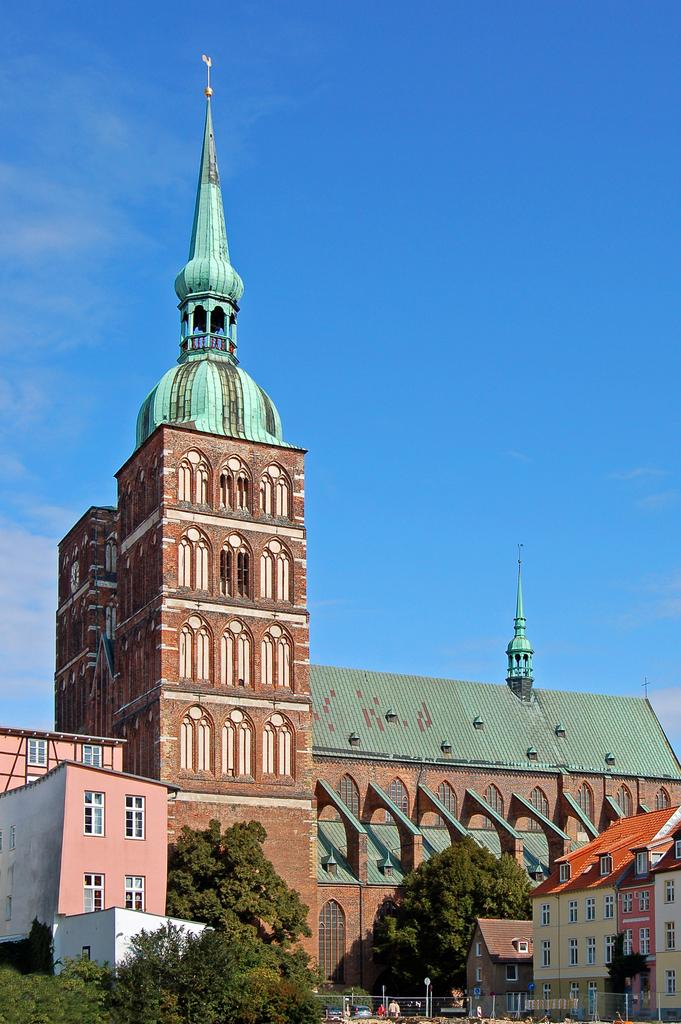What type of structures can be seen in the image? There are buildings in the image. What type of vegetation is present in the image? There are trees in the image. What type of ground surface is visible in the image? There is grass visible in the image. Are there any living beings present in the image? Yes, there are people present in the image. What part of the natural environment is visible in the image? The sky is visible in the image. Can you tell me how many patches are visible on the grass in the image? There is no mention of patches on the grass in the image. What type of laborer can be seen working in the image? There is no laborer present in the image. Is there a volleyball game taking place in the image? There is no indication of a volleyball game in the image. 